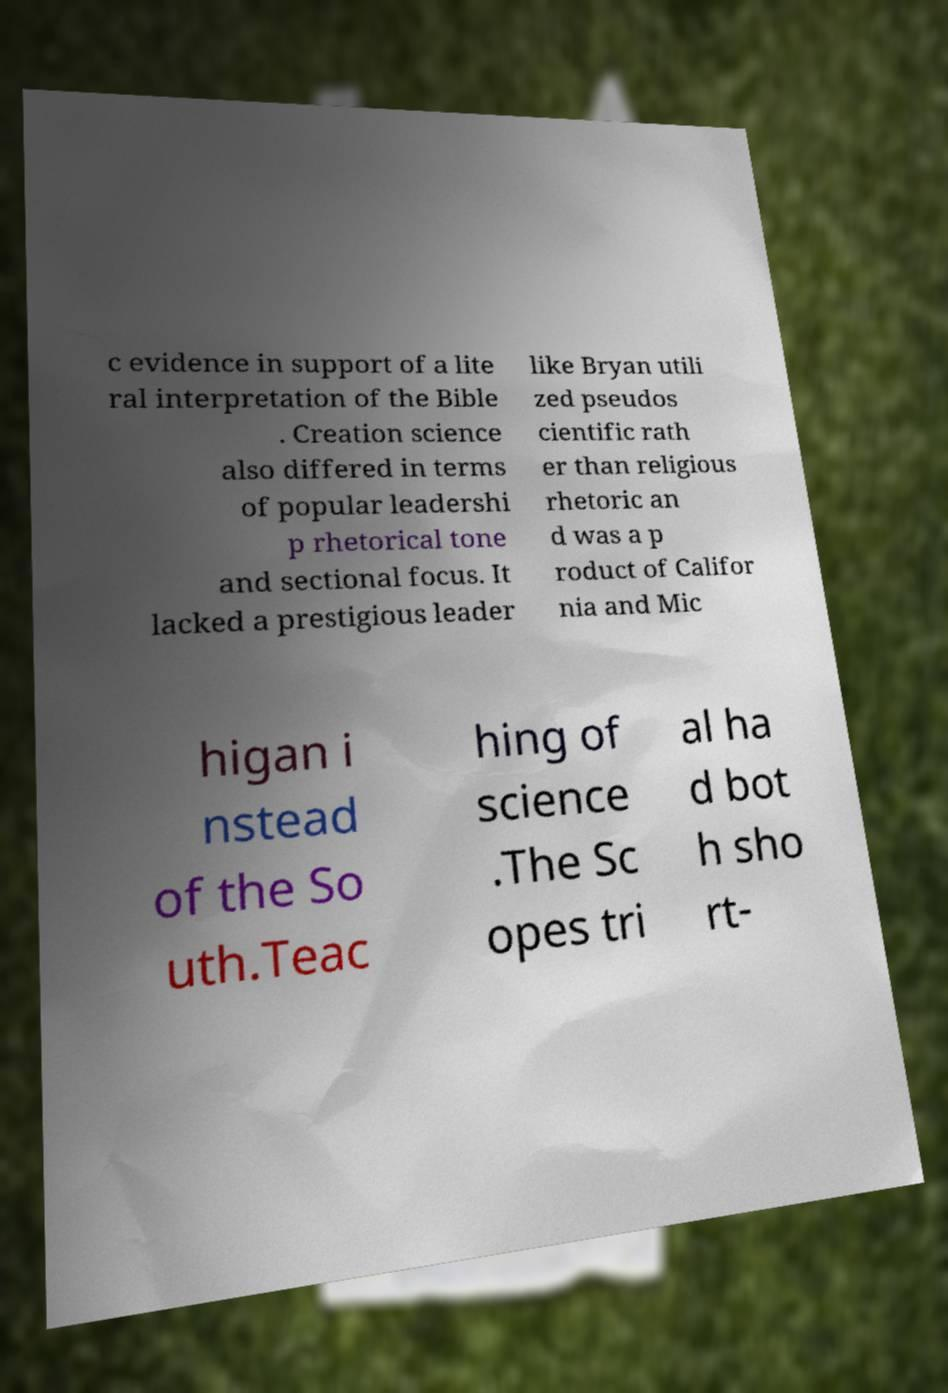There's text embedded in this image that I need extracted. Can you transcribe it verbatim? c evidence in support of a lite ral interpretation of the Bible . Creation science also differed in terms of popular leadershi p rhetorical tone and sectional focus. It lacked a prestigious leader like Bryan utili zed pseudos cientific rath er than religious rhetoric an d was a p roduct of Califor nia and Mic higan i nstead of the So uth.Teac hing of science .The Sc opes tri al ha d bot h sho rt- 